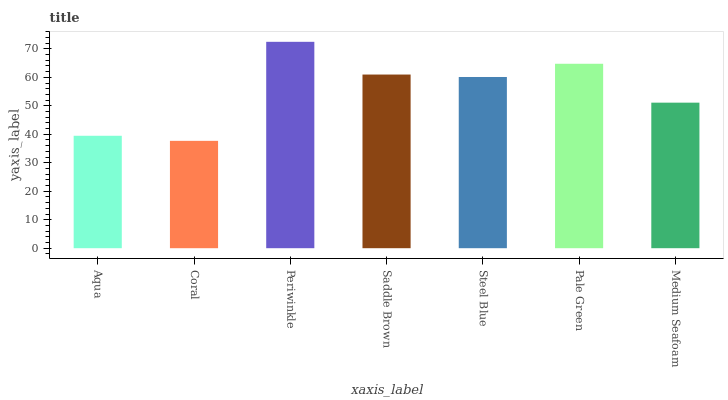Is Coral the minimum?
Answer yes or no. Yes. Is Periwinkle the maximum?
Answer yes or no. Yes. Is Periwinkle the minimum?
Answer yes or no. No. Is Coral the maximum?
Answer yes or no. No. Is Periwinkle greater than Coral?
Answer yes or no. Yes. Is Coral less than Periwinkle?
Answer yes or no. Yes. Is Coral greater than Periwinkle?
Answer yes or no. No. Is Periwinkle less than Coral?
Answer yes or no. No. Is Steel Blue the high median?
Answer yes or no. Yes. Is Steel Blue the low median?
Answer yes or no. Yes. Is Periwinkle the high median?
Answer yes or no. No. Is Saddle Brown the low median?
Answer yes or no. No. 